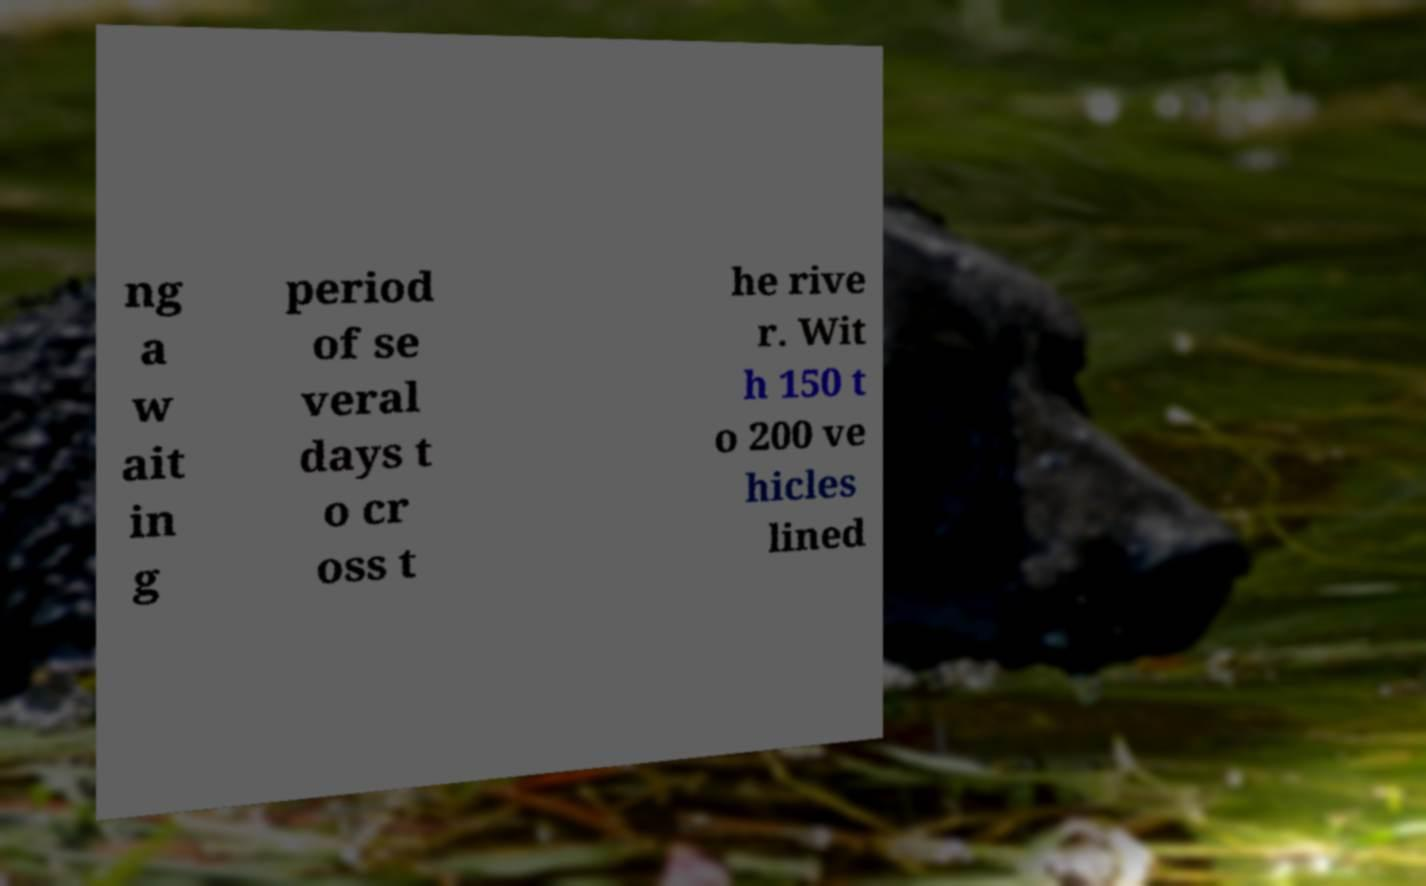Could you assist in decoding the text presented in this image and type it out clearly? ng a w ait in g period of se veral days t o cr oss t he rive r. Wit h 150 t o 200 ve hicles lined 